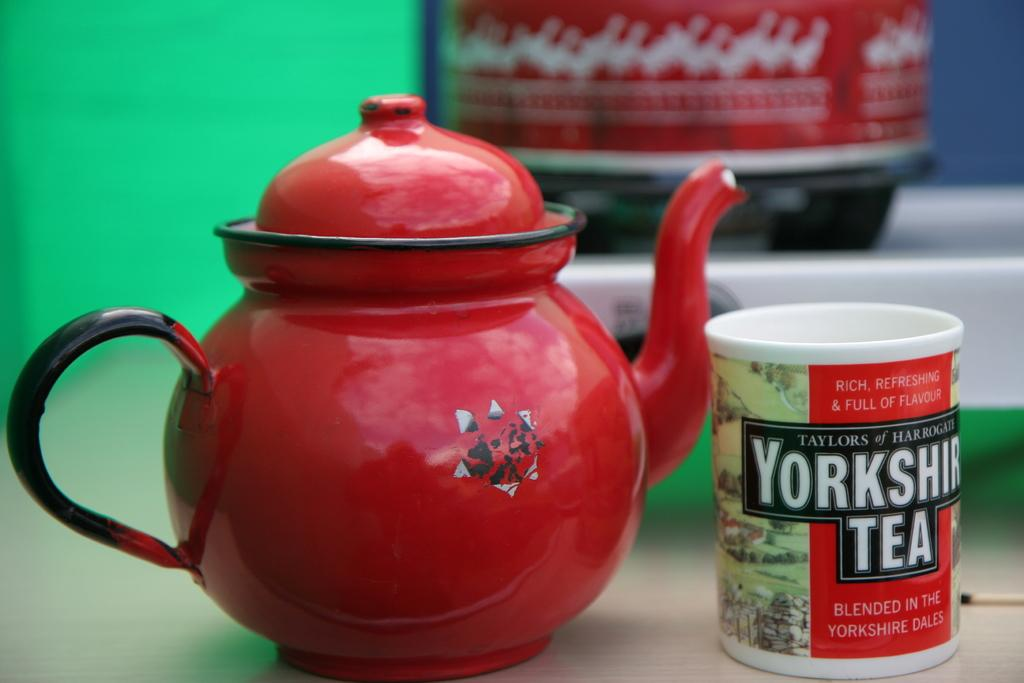What is the main object in the image? There is a teapot in the image. What other object is visible in the image? There is a mug in the image. Can you describe the objects behind the teapot? Unfortunately, the facts provided do not give any information about the objects behind the teapot. How many waves can be seen crashing on the shore in the image? There are no waves present in the image; it features a teapot and a mug. What type of sticks are used to stir the tea in the image? There are no sticks present in the image, and it is not clear if the tea is being stirred. 